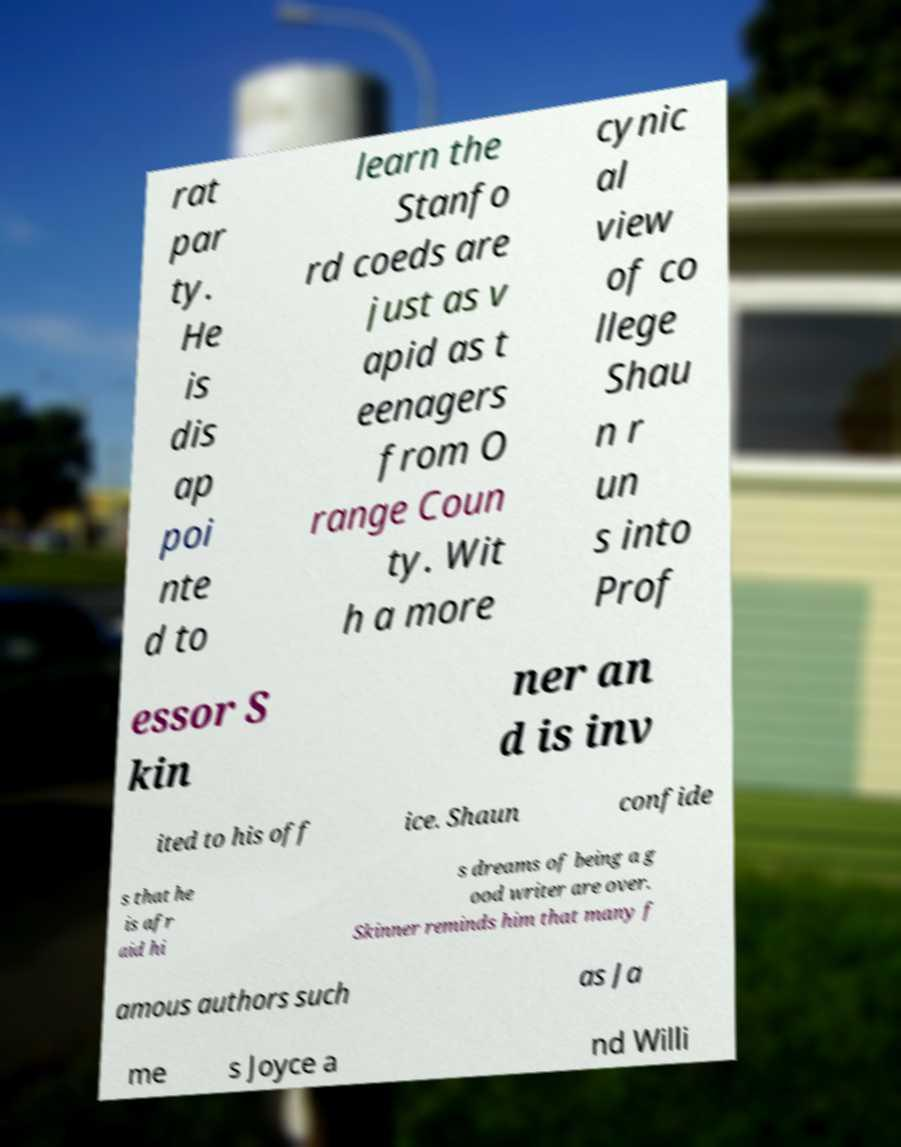Can you accurately transcribe the text from the provided image for me? rat par ty. He is dis ap poi nte d to learn the Stanfo rd coeds are just as v apid as t eenagers from O range Coun ty. Wit h a more cynic al view of co llege Shau n r un s into Prof essor S kin ner an d is inv ited to his off ice. Shaun confide s that he is afr aid hi s dreams of being a g ood writer are over. Skinner reminds him that many f amous authors such as Ja me s Joyce a nd Willi 